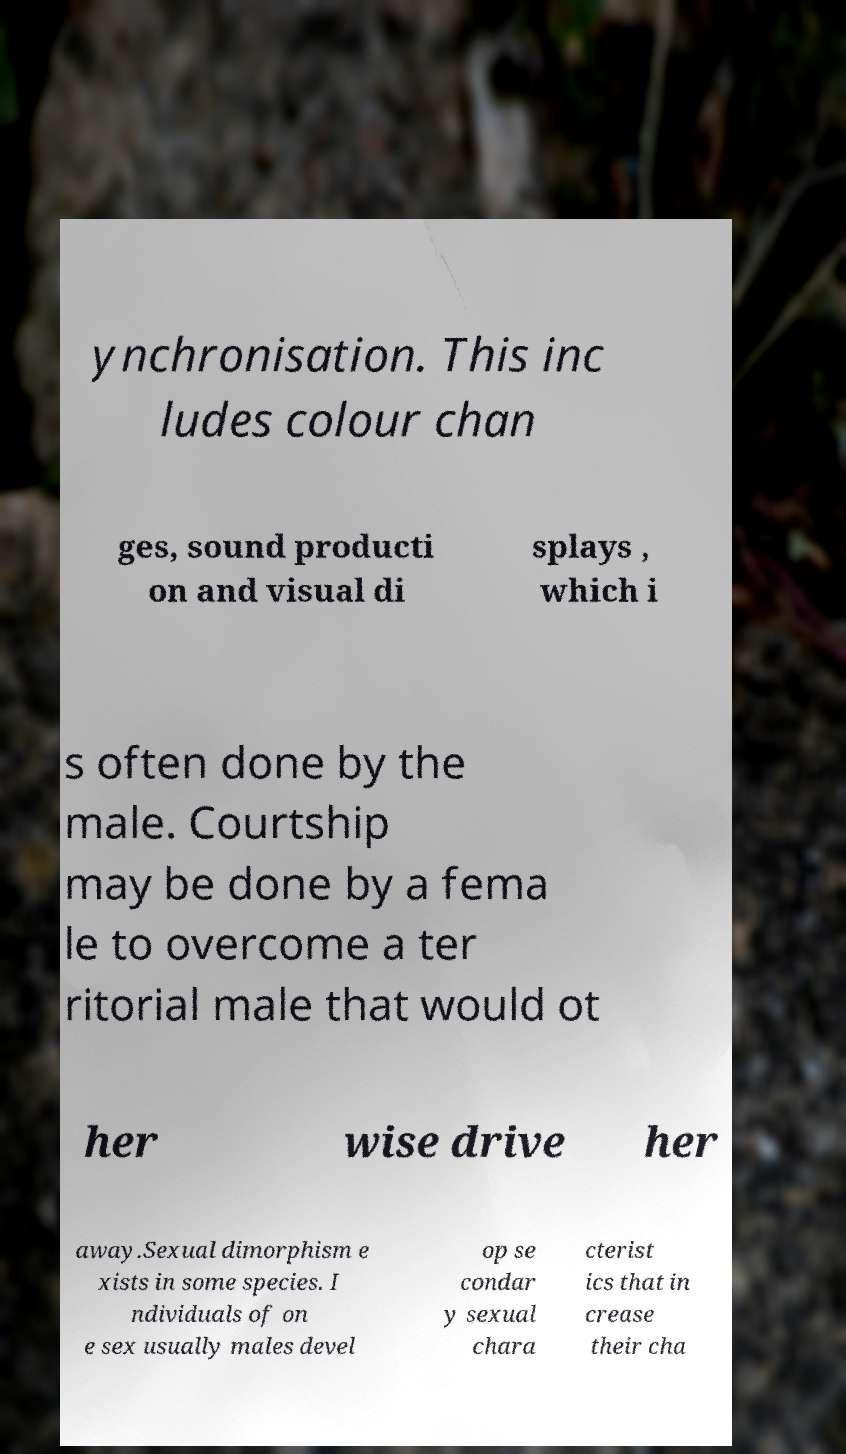For documentation purposes, I need the text within this image transcribed. Could you provide that? ynchronisation. This inc ludes colour chan ges, sound producti on and visual di splays , which i s often done by the male. Courtship may be done by a fema le to overcome a ter ritorial male that would ot her wise drive her away.Sexual dimorphism e xists in some species. I ndividuals of on e sex usually males devel op se condar y sexual chara cterist ics that in crease their cha 